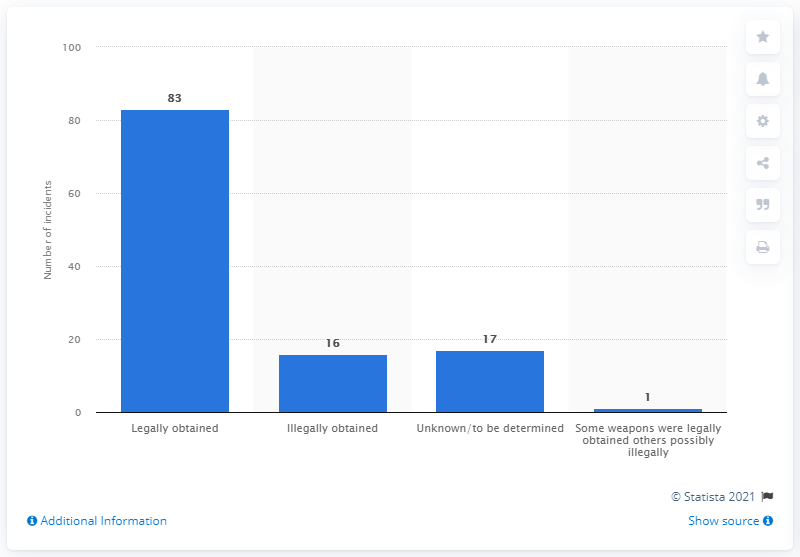Highlight a few significant elements in this photo. The number of mass shootings between 1982 and 2021 was 16. There have been 83 mass shootings between 1982 and 2021. 